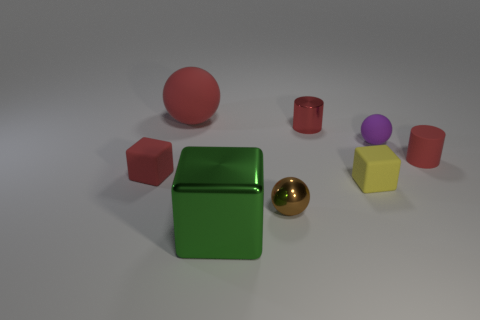There is a tiny cube left of the large red sphere; is it the same color as the big rubber ball?
Provide a succinct answer. Yes. Do the rubber object that is left of the big sphere and the rubber ball that is on the left side of the green metal object have the same color?
Your response must be concise. Yes. What is the material of the brown thing that is the same size as the red rubber cube?
Offer a very short reply. Metal. There is a tiny object that is left of the green block; what shape is it?
Your answer should be very brief. Cube. Does the red object to the left of the big red rubber object have the same material as the large object in front of the brown metallic ball?
Provide a succinct answer. No. What number of other tiny yellow objects are the same shape as the yellow rubber thing?
Your answer should be compact. 0. What material is the tiny cube that is the same color as the big ball?
Give a very brief answer. Rubber. How many things are either small yellow objects or cubes to the right of the large red matte object?
Offer a very short reply. 2. What is the material of the big red sphere?
Make the answer very short. Rubber. What is the material of the yellow object that is the same shape as the green object?
Your answer should be very brief. Rubber. 